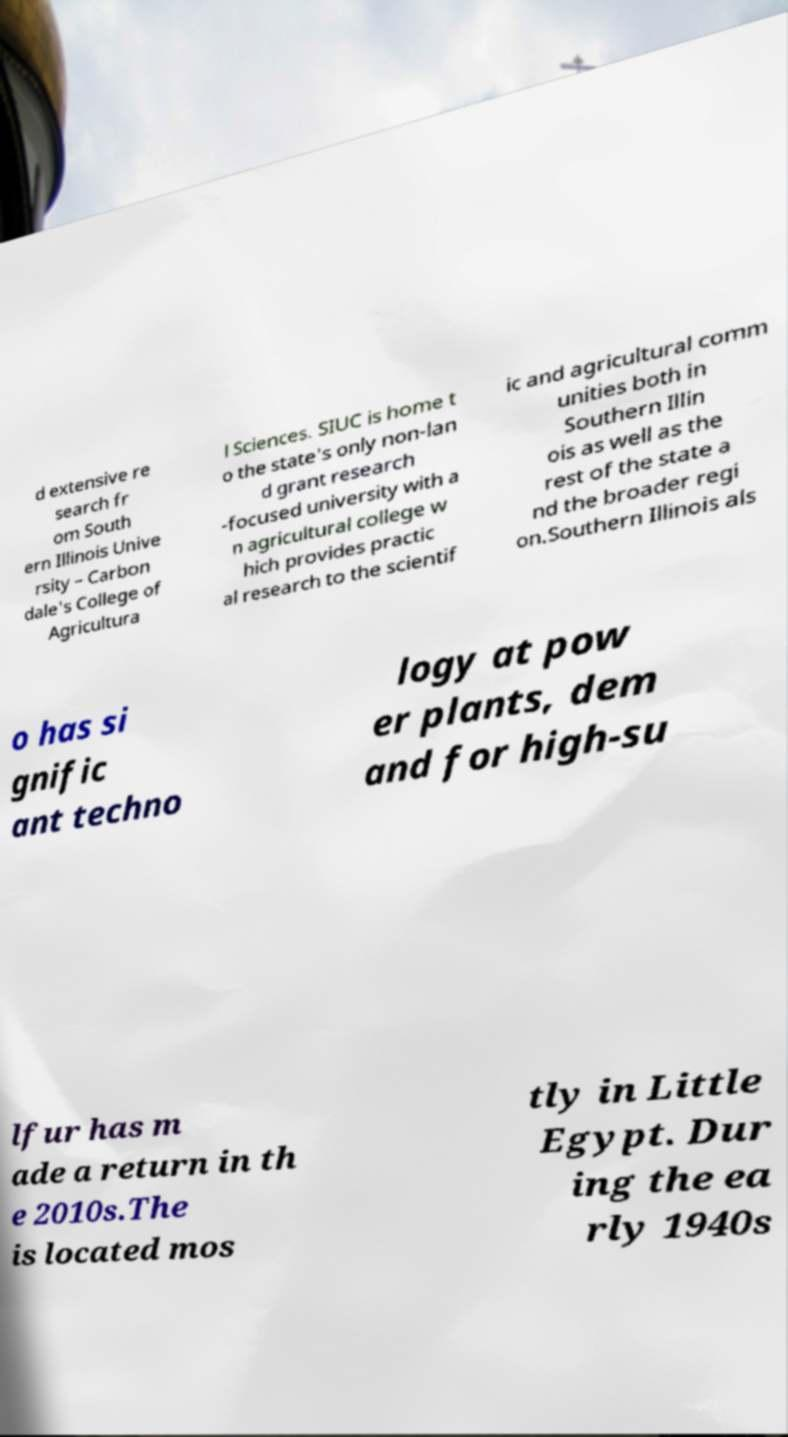Could you assist in decoding the text presented in this image and type it out clearly? d extensive re search fr om South ern Illinois Unive rsity – Carbon dale's College of Agricultura l Sciences. SIUC is home t o the state's only non-lan d grant research -focused university with a n agricultural college w hich provides practic al research to the scientif ic and agricultural comm unities both in Southern Illin ois as well as the rest of the state a nd the broader regi on.Southern Illinois als o has si gnific ant techno logy at pow er plants, dem and for high-su lfur has m ade a return in th e 2010s.The is located mos tly in Little Egypt. Dur ing the ea rly 1940s 